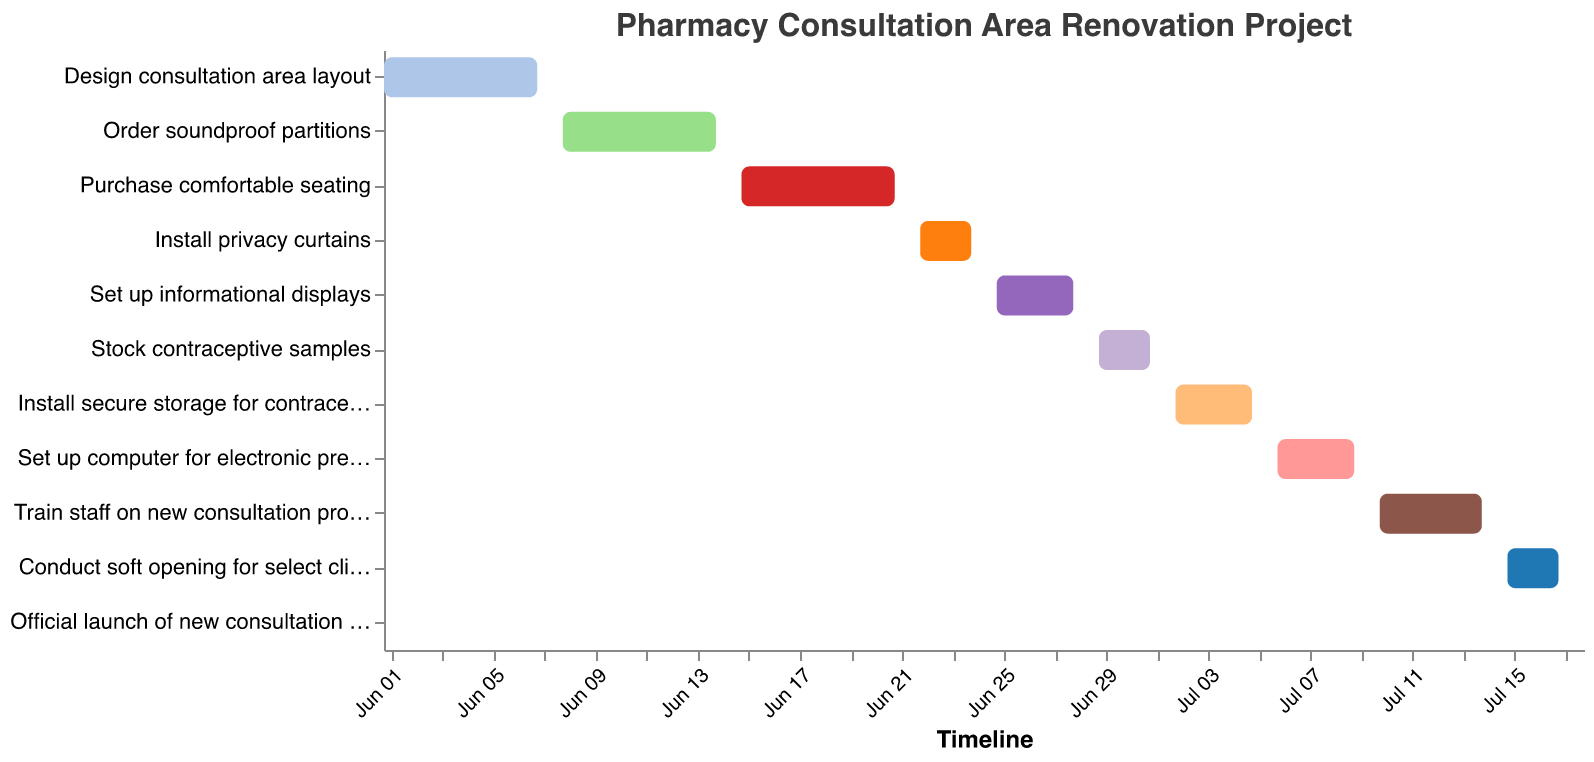What's the title of the Gantt Chart? The title is located at the top of the chart and clearly states the subject of the Gantt Chart.
Answer: Pharmacy Consultation Area Renovation Project What is the duration of the "Train staff on new consultation procedures" task? The duration of this task can be found directly in the data by identifying the row for "Train staff on new consultation procedures" and examining the "Duration (days)" field.
Answer: 5 days Which task starts immediately after "Order soundproof partitions"? To find the task that starts after "Order soundproof partitions," look at the end date of "Order soundproof partitions" and find the task with a start date directly after this. The end date for "Order soundproof partitions" is 2023-06-14, so the task starting on 2023-06-15 is "Purchase comfortable seating."
Answer: Purchase comfortable seating How long does the "Set up informational displays" task take, and what is its end date? The duration and end date for "Set up informational displays" are found by identifying the relevant row in the data and noting the "Duration (days)" and "End Date" fields. The task duration is 4 days, and the end date is 2023-06-28.
Answer: 4 days, 2023-06-28 Which task has the shortest duration, and how long is it? To determine the shortest task, compare the durations of all tasks. The task "Official launch of new consultation area" has the shortest duration of 1 day.
Answer: Official launch of new consultation area, 1 day What is the total duration to complete all tasks in the project? To find the total duration, note the start date of the first task (2023-06-01) and the end date of the last task (2023-07-18) and calculate the difference in days. The total duration is from June 1 to July 18, which is 48 days.
Answer: 48 days Which tasks have overlapping durations? To find overlapping tasks, visually inspect the chart or compare start and end dates of tasks. "Purchase comfortable seating" (2023-06-15 to 2023-06-21) overlaps with "Install privacy curtains" (2023-06-22 to 2023-06-24).
Answer: Purchase comfortable seating and Install privacy curtains Which task requires the latest start date in the project timeline? The task with the latest start date will be at the end of the timeline. "Official launch of new consultation area" starts on 2023-07-18.
Answer: Official launch of new consultation area How many tasks have a duration of exactly 3 days? Count the tasks with a "Duration (days)" value of 3. There are three tasks: "Install privacy curtains," "Stock contraceptive samples," and "Conduct soft opening for select clients."
Answer: 3 tasks What task ends on July 5th, and what is the next task to start after this? The task ending on July 5th is "Install secure storage for contraceptives." The next task to start is "Set up computer for electronic prescribing," which starts on July 6th.
Answer: Install secure storage for contraceptives, Set up computer for electronic prescribing 